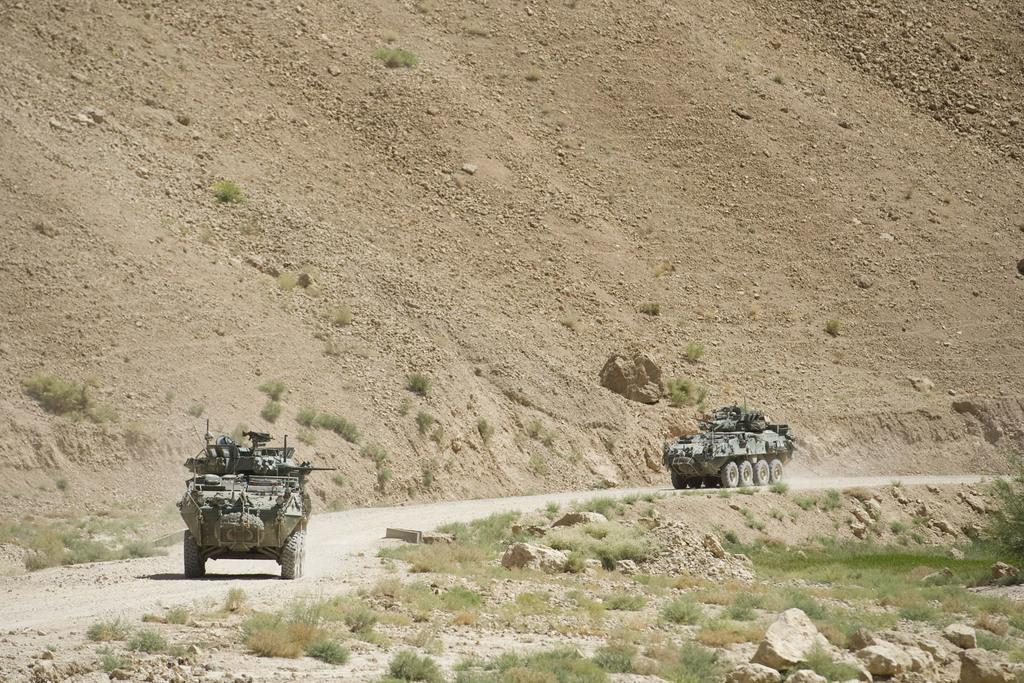What can be seen on the path in the image? There are vehicles on the path in the image. What type of vegetation is visible on the path? There is grass visible on the path. What else is present on the path? Stones are present on the path. What can be seen in the distance in the image? There is a mountain in the background of the image. What type of skin condition is visible on the mountain in the image? There is no skin condition visible in the image, as the mountain is a geological feature and not a living organism. What type of plant is growing on the vehicles in the image? There are no plants growing on the vehicles in the image; they are not present. 